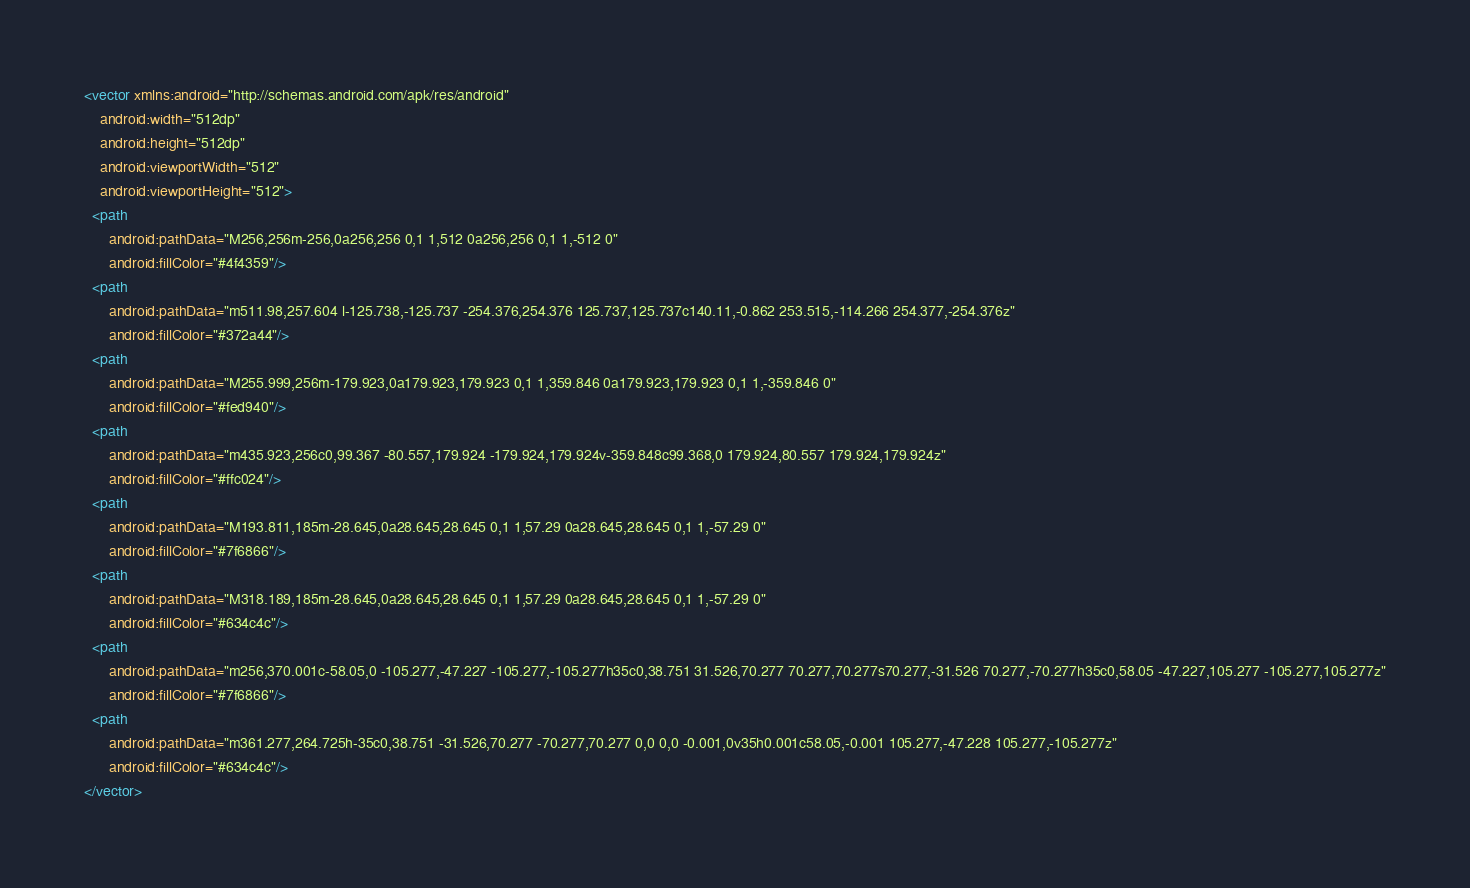<code> <loc_0><loc_0><loc_500><loc_500><_XML_><vector xmlns:android="http://schemas.android.com/apk/res/android"
    android:width="512dp"
    android:height="512dp"
    android:viewportWidth="512"
    android:viewportHeight="512">
  <path
      android:pathData="M256,256m-256,0a256,256 0,1 1,512 0a256,256 0,1 1,-512 0"
      android:fillColor="#4f4359"/>
  <path
      android:pathData="m511.98,257.604 l-125.738,-125.737 -254.376,254.376 125.737,125.737c140.11,-0.862 253.515,-114.266 254.377,-254.376z"
      android:fillColor="#372a44"/>
  <path
      android:pathData="M255.999,256m-179.923,0a179.923,179.923 0,1 1,359.846 0a179.923,179.923 0,1 1,-359.846 0"
      android:fillColor="#fed940"/>
  <path
      android:pathData="m435.923,256c0,99.367 -80.557,179.924 -179.924,179.924v-359.848c99.368,0 179.924,80.557 179.924,179.924z"
      android:fillColor="#ffc024"/>
  <path
      android:pathData="M193.811,185m-28.645,0a28.645,28.645 0,1 1,57.29 0a28.645,28.645 0,1 1,-57.29 0"
      android:fillColor="#7f6866"/>
  <path
      android:pathData="M318.189,185m-28.645,0a28.645,28.645 0,1 1,57.29 0a28.645,28.645 0,1 1,-57.29 0"
      android:fillColor="#634c4c"/>
  <path
      android:pathData="m256,370.001c-58.05,0 -105.277,-47.227 -105.277,-105.277h35c0,38.751 31.526,70.277 70.277,70.277s70.277,-31.526 70.277,-70.277h35c0,58.05 -47.227,105.277 -105.277,105.277z"
      android:fillColor="#7f6866"/>
  <path
      android:pathData="m361.277,264.725h-35c0,38.751 -31.526,70.277 -70.277,70.277 0,0 0,0 -0.001,0v35h0.001c58.05,-0.001 105.277,-47.228 105.277,-105.277z"
      android:fillColor="#634c4c"/>
</vector>
</code> 